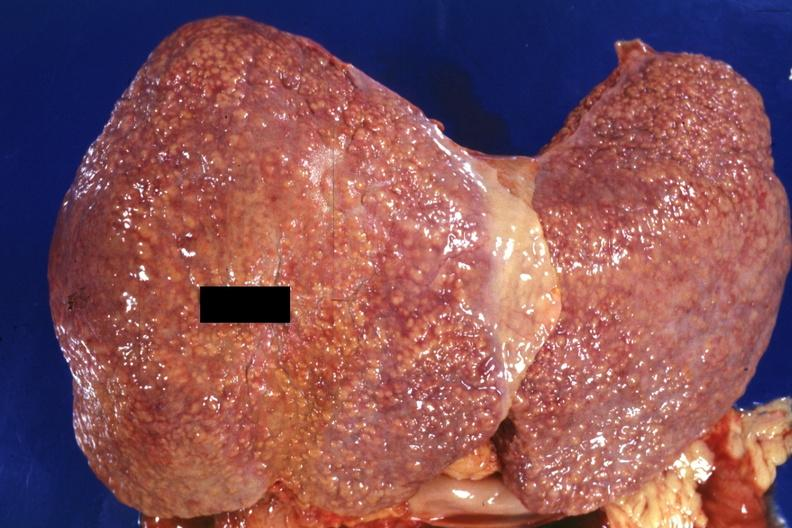s hepatobiliary present?
Answer the question using a single word or phrase. Yes 